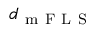<formula> <loc_0><loc_0><loc_500><loc_500>d _ { m F L S }</formula> 